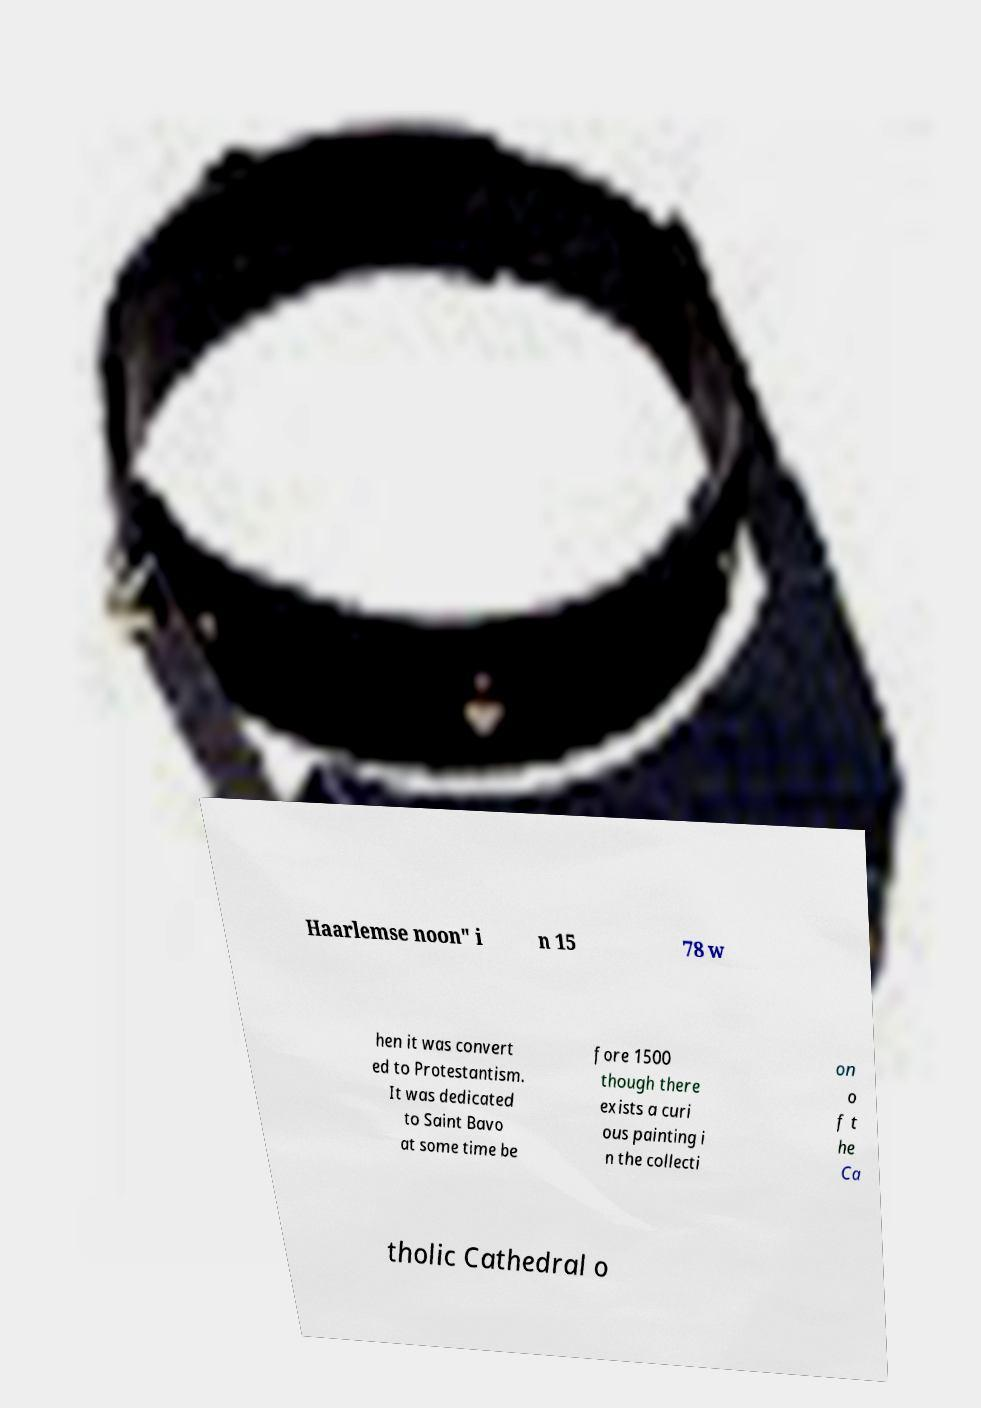There's text embedded in this image that I need extracted. Can you transcribe it verbatim? Haarlemse noon" i n 15 78 w hen it was convert ed to Protestantism. It was dedicated to Saint Bavo at some time be fore 1500 though there exists a curi ous painting i n the collecti on o f t he Ca tholic Cathedral o 